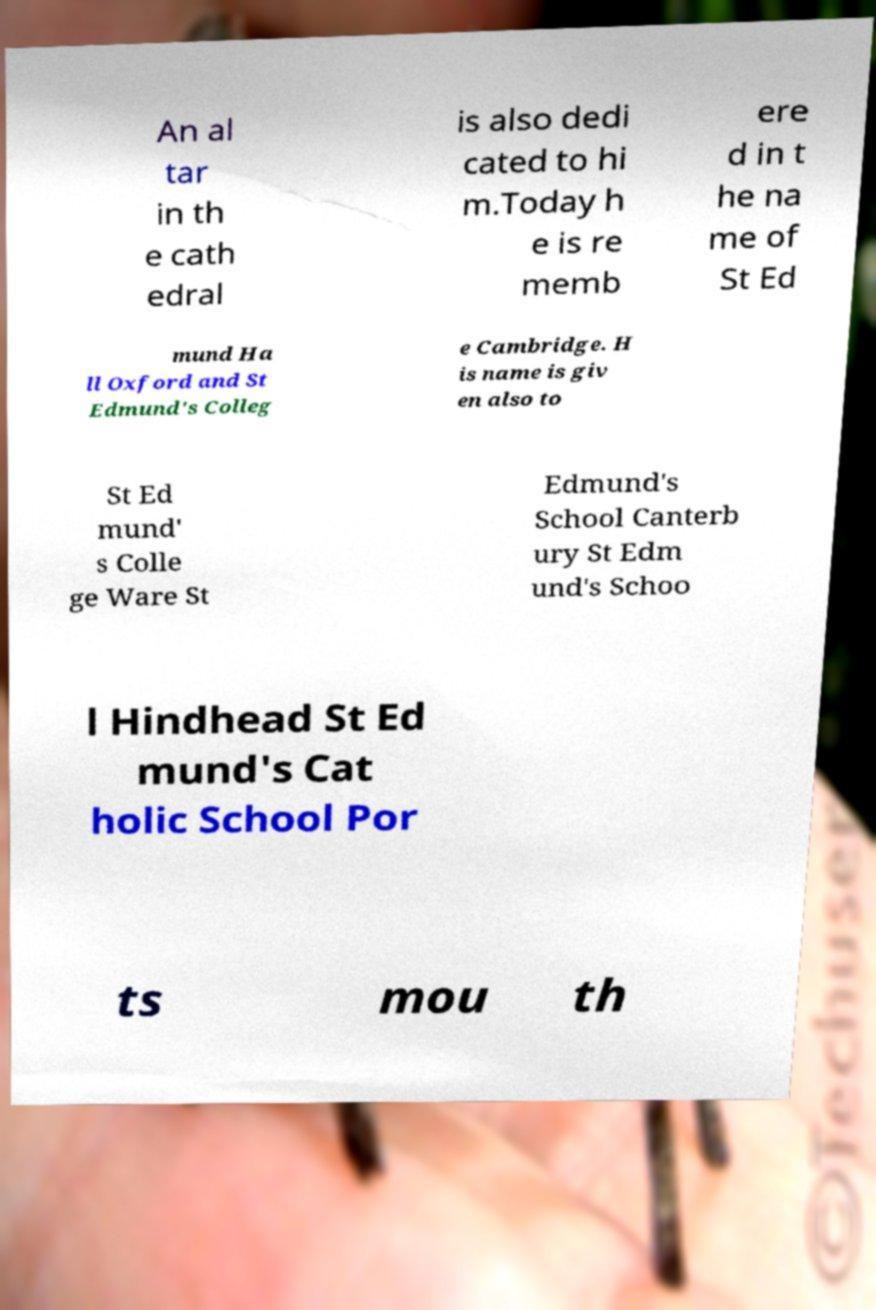Could you assist in decoding the text presented in this image and type it out clearly? An al tar in th e cath edral is also dedi cated to hi m.Today h e is re memb ere d in t he na me of St Ed mund Ha ll Oxford and St Edmund's Colleg e Cambridge. H is name is giv en also to St Ed mund' s Colle ge Ware St Edmund's School Canterb ury St Edm und's Schoo l Hindhead St Ed mund's Cat holic School Por ts mou th 